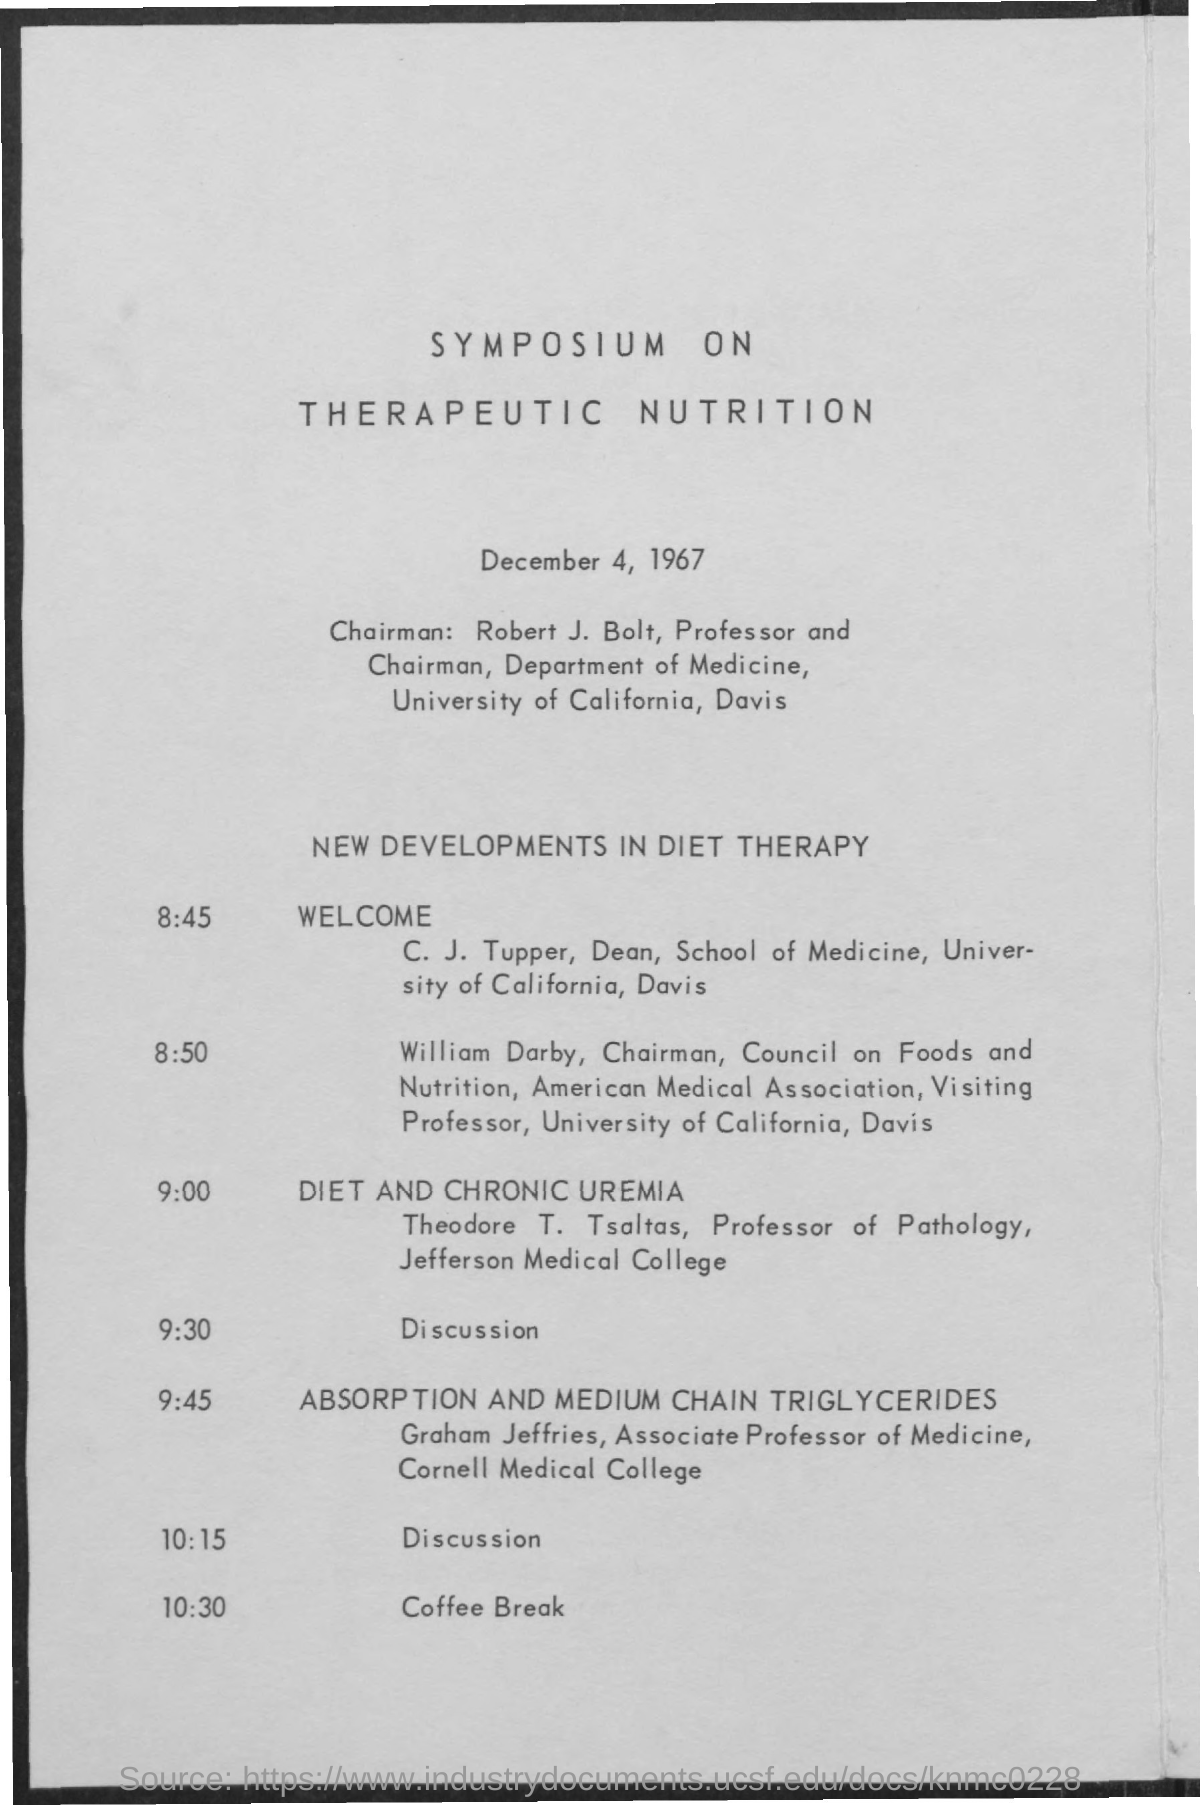Indicate a few pertinent items in this graphic. It is Robert J. Bolt who serves as the chairman of the department of medicine. ROBERT J. BOLT is the Chairman. The date mentioned in the document is December 4, 1967. The professor of pathology at Jefferson Medical College is Theodore T. Tsaltas. The chairman of the council on foods and nutrition is William Darby. 